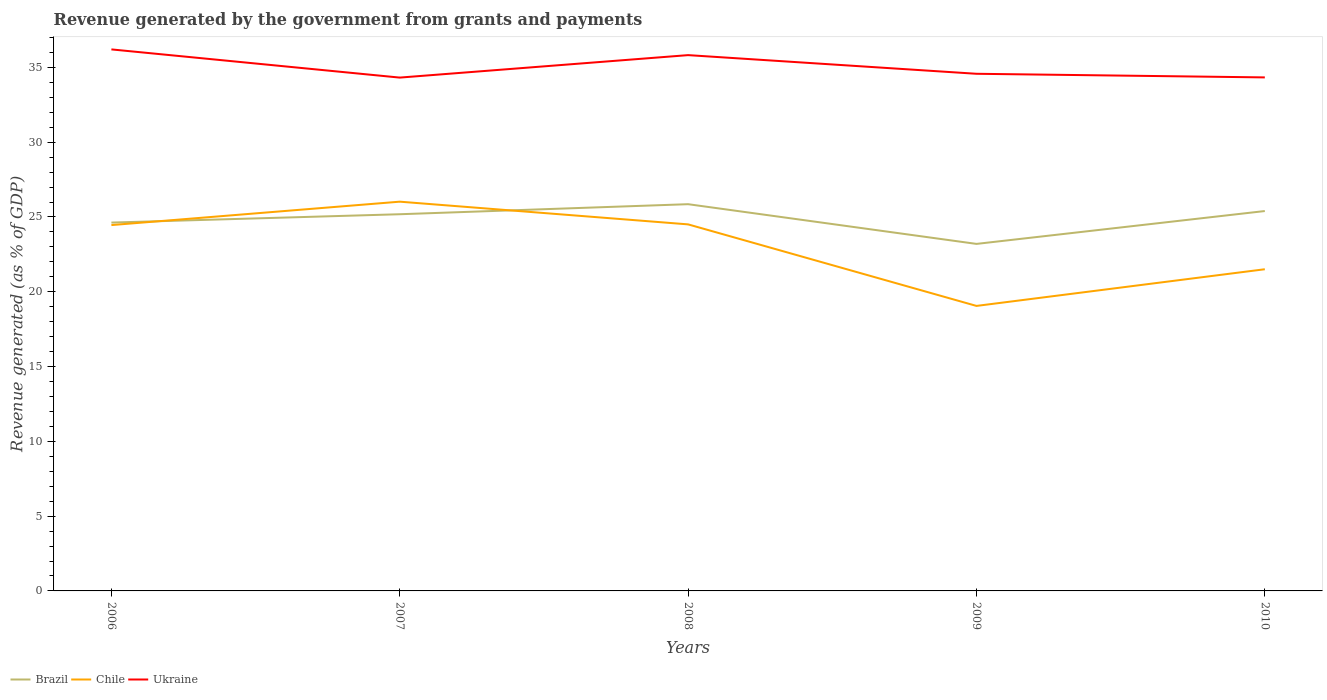How many different coloured lines are there?
Your answer should be very brief. 3. Is the number of lines equal to the number of legend labels?
Give a very brief answer. Yes. Across all years, what is the maximum revenue generated by the government in Chile?
Your answer should be compact. 19.05. In which year was the revenue generated by the government in Chile maximum?
Offer a very short reply. 2009. What is the total revenue generated by the government in Chile in the graph?
Your answer should be compact. 5.4. What is the difference between the highest and the second highest revenue generated by the government in Ukraine?
Provide a short and direct response. 1.88. How many lines are there?
Give a very brief answer. 3. What is the difference between two consecutive major ticks on the Y-axis?
Offer a terse response. 5. Does the graph contain any zero values?
Make the answer very short. No. Where does the legend appear in the graph?
Offer a terse response. Bottom left. What is the title of the graph?
Make the answer very short. Revenue generated by the government from grants and payments. What is the label or title of the Y-axis?
Your response must be concise. Revenue generated (as % of GDP). What is the Revenue generated (as % of GDP) in Brazil in 2006?
Make the answer very short. 24.63. What is the Revenue generated (as % of GDP) in Chile in 2006?
Your answer should be very brief. 24.46. What is the Revenue generated (as % of GDP) in Ukraine in 2006?
Make the answer very short. 36.2. What is the Revenue generated (as % of GDP) in Brazil in 2007?
Give a very brief answer. 25.18. What is the Revenue generated (as % of GDP) in Chile in 2007?
Your response must be concise. 26.02. What is the Revenue generated (as % of GDP) of Ukraine in 2007?
Your answer should be compact. 34.32. What is the Revenue generated (as % of GDP) in Brazil in 2008?
Provide a short and direct response. 25.86. What is the Revenue generated (as % of GDP) of Chile in 2008?
Ensure brevity in your answer.  24.51. What is the Revenue generated (as % of GDP) of Ukraine in 2008?
Keep it short and to the point. 35.82. What is the Revenue generated (as % of GDP) in Brazil in 2009?
Keep it short and to the point. 23.2. What is the Revenue generated (as % of GDP) in Chile in 2009?
Provide a succinct answer. 19.05. What is the Revenue generated (as % of GDP) in Ukraine in 2009?
Ensure brevity in your answer.  34.58. What is the Revenue generated (as % of GDP) in Brazil in 2010?
Provide a short and direct response. 25.4. What is the Revenue generated (as % of GDP) of Chile in 2010?
Make the answer very short. 21.51. What is the Revenue generated (as % of GDP) of Ukraine in 2010?
Your answer should be compact. 34.33. Across all years, what is the maximum Revenue generated (as % of GDP) of Brazil?
Provide a succinct answer. 25.86. Across all years, what is the maximum Revenue generated (as % of GDP) of Chile?
Provide a short and direct response. 26.02. Across all years, what is the maximum Revenue generated (as % of GDP) of Ukraine?
Provide a short and direct response. 36.2. Across all years, what is the minimum Revenue generated (as % of GDP) of Brazil?
Offer a terse response. 23.2. Across all years, what is the minimum Revenue generated (as % of GDP) in Chile?
Offer a terse response. 19.05. Across all years, what is the minimum Revenue generated (as % of GDP) in Ukraine?
Your answer should be compact. 34.32. What is the total Revenue generated (as % of GDP) in Brazil in the graph?
Your response must be concise. 124.27. What is the total Revenue generated (as % of GDP) of Chile in the graph?
Give a very brief answer. 115.55. What is the total Revenue generated (as % of GDP) of Ukraine in the graph?
Provide a succinct answer. 175.25. What is the difference between the Revenue generated (as % of GDP) of Brazil in 2006 and that in 2007?
Offer a terse response. -0.56. What is the difference between the Revenue generated (as % of GDP) in Chile in 2006 and that in 2007?
Make the answer very short. -1.57. What is the difference between the Revenue generated (as % of GDP) in Ukraine in 2006 and that in 2007?
Provide a succinct answer. 1.88. What is the difference between the Revenue generated (as % of GDP) in Brazil in 2006 and that in 2008?
Ensure brevity in your answer.  -1.23. What is the difference between the Revenue generated (as % of GDP) in Chile in 2006 and that in 2008?
Keep it short and to the point. -0.05. What is the difference between the Revenue generated (as % of GDP) of Ukraine in 2006 and that in 2008?
Offer a very short reply. 0.38. What is the difference between the Revenue generated (as % of GDP) in Brazil in 2006 and that in 2009?
Offer a very short reply. 1.43. What is the difference between the Revenue generated (as % of GDP) in Chile in 2006 and that in 2009?
Provide a succinct answer. 5.4. What is the difference between the Revenue generated (as % of GDP) of Ukraine in 2006 and that in 2009?
Your answer should be very brief. 1.63. What is the difference between the Revenue generated (as % of GDP) in Brazil in 2006 and that in 2010?
Give a very brief answer. -0.77. What is the difference between the Revenue generated (as % of GDP) in Chile in 2006 and that in 2010?
Provide a succinct answer. 2.95. What is the difference between the Revenue generated (as % of GDP) in Ukraine in 2006 and that in 2010?
Ensure brevity in your answer.  1.87. What is the difference between the Revenue generated (as % of GDP) of Brazil in 2007 and that in 2008?
Ensure brevity in your answer.  -0.67. What is the difference between the Revenue generated (as % of GDP) of Chile in 2007 and that in 2008?
Your answer should be very brief. 1.52. What is the difference between the Revenue generated (as % of GDP) in Ukraine in 2007 and that in 2008?
Ensure brevity in your answer.  -1.5. What is the difference between the Revenue generated (as % of GDP) in Brazil in 2007 and that in 2009?
Make the answer very short. 1.98. What is the difference between the Revenue generated (as % of GDP) of Chile in 2007 and that in 2009?
Your answer should be very brief. 6.97. What is the difference between the Revenue generated (as % of GDP) of Ukraine in 2007 and that in 2009?
Provide a succinct answer. -0.26. What is the difference between the Revenue generated (as % of GDP) in Brazil in 2007 and that in 2010?
Provide a succinct answer. -0.21. What is the difference between the Revenue generated (as % of GDP) of Chile in 2007 and that in 2010?
Your answer should be very brief. 4.52. What is the difference between the Revenue generated (as % of GDP) of Ukraine in 2007 and that in 2010?
Give a very brief answer. -0.01. What is the difference between the Revenue generated (as % of GDP) of Brazil in 2008 and that in 2009?
Your response must be concise. 2.65. What is the difference between the Revenue generated (as % of GDP) of Chile in 2008 and that in 2009?
Provide a succinct answer. 5.45. What is the difference between the Revenue generated (as % of GDP) of Ukraine in 2008 and that in 2009?
Make the answer very short. 1.25. What is the difference between the Revenue generated (as % of GDP) in Brazil in 2008 and that in 2010?
Keep it short and to the point. 0.46. What is the difference between the Revenue generated (as % of GDP) in Chile in 2008 and that in 2010?
Provide a short and direct response. 3. What is the difference between the Revenue generated (as % of GDP) of Ukraine in 2008 and that in 2010?
Provide a succinct answer. 1.49. What is the difference between the Revenue generated (as % of GDP) of Brazil in 2009 and that in 2010?
Make the answer very short. -2.2. What is the difference between the Revenue generated (as % of GDP) in Chile in 2009 and that in 2010?
Your response must be concise. -2.45. What is the difference between the Revenue generated (as % of GDP) of Ukraine in 2009 and that in 2010?
Your answer should be compact. 0.24. What is the difference between the Revenue generated (as % of GDP) in Brazil in 2006 and the Revenue generated (as % of GDP) in Chile in 2007?
Provide a short and direct response. -1.4. What is the difference between the Revenue generated (as % of GDP) of Brazil in 2006 and the Revenue generated (as % of GDP) of Ukraine in 2007?
Your answer should be very brief. -9.69. What is the difference between the Revenue generated (as % of GDP) of Chile in 2006 and the Revenue generated (as % of GDP) of Ukraine in 2007?
Offer a very short reply. -9.86. What is the difference between the Revenue generated (as % of GDP) in Brazil in 2006 and the Revenue generated (as % of GDP) in Chile in 2008?
Your response must be concise. 0.12. What is the difference between the Revenue generated (as % of GDP) of Brazil in 2006 and the Revenue generated (as % of GDP) of Ukraine in 2008?
Offer a terse response. -11.2. What is the difference between the Revenue generated (as % of GDP) in Chile in 2006 and the Revenue generated (as % of GDP) in Ukraine in 2008?
Give a very brief answer. -11.36. What is the difference between the Revenue generated (as % of GDP) of Brazil in 2006 and the Revenue generated (as % of GDP) of Chile in 2009?
Your answer should be very brief. 5.57. What is the difference between the Revenue generated (as % of GDP) of Brazil in 2006 and the Revenue generated (as % of GDP) of Ukraine in 2009?
Keep it short and to the point. -9.95. What is the difference between the Revenue generated (as % of GDP) in Chile in 2006 and the Revenue generated (as % of GDP) in Ukraine in 2009?
Provide a succinct answer. -10.12. What is the difference between the Revenue generated (as % of GDP) of Brazil in 2006 and the Revenue generated (as % of GDP) of Chile in 2010?
Your answer should be compact. 3.12. What is the difference between the Revenue generated (as % of GDP) in Brazil in 2006 and the Revenue generated (as % of GDP) in Ukraine in 2010?
Offer a terse response. -9.71. What is the difference between the Revenue generated (as % of GDP) in Chile in 2006 and the Revenue generated (as % of GDP) in Ukraine in 2010?
Ensure brevity in your answer.  -9.87. What is the difference between the Revenue generated (as % of GDP) of Brazil in 2007 and the Revenue generated (as % of GDP) of Chile in 2008?
Your answer should be compact. 0.68. What is the difference between the Revenue generated (as % of GDP) in Brazil in 2007 and the Revenue generated (as % of GDP) in Ukraine in 2008?
Your response must be concise. -10.64. What is the difference between the Revenue generated (as % of GDP) in Chile in 2007 and the Revenue generated (as % of GDP) in Ukraine in 2008?
Your answer should be very brief. -9.8. What is the difference between the Revenue generated (as % of GDP) in Brazil in 2007 and the Revenue generated (as % of GDP) in Chile in 2009?
Give a very brief answer. 6.13. What is the difference between the Revenue generated (as % of GDP) of Brazil in 2007 and the Revenue generated (as % of GDP) of Ukraine in 2009?
Provide a short and direct response. -9.39. What is the difference between the Revenue generated (as % of GDP) of Chile in 2007 and the Revenue generated (as % of GDP) of Ukraine in 2009?
Your answer should be very brief. -8.55. What is the difference between the Revenue generated (as % of GDP) in Brazil in 2007 and the Revenue generated (as % of GDP) in Chile in 2010?
Offer a very short reply. 3.68. What is the difference between the Revenue generated (as % of GDP) in Brazil in 2007 and the Revenue generated (as % of GDP) in Ukraine in 2010?
Give a very brief answer. -9.15. What is the difference between the Revenue generated (as % of GDP) in Chile in 2007 and the Revenue generated (as % of GDP) in Ukraine in 2010?
Keep it short and to the point. -8.31. What is the difference between the Revenue generated (as % of GDP) of Brazil in 2008 and the Revenue generated (as % of GDP) of Chile in 2009?
Your response must be concise. 6.8. What is the difference between the Revenue generated (as % of GDP) of Brazil in 2008 and the Revenue generated (as % of GDP) of Ukraine in 2009?
Your answer should be compact. -8.72. What is the difference between the Revenue generated (as % of GDP) of Chile in 2008 and the Revenue generated (as % of GDP) of Ukraine in 2009?
Your answer should be compact. -10.07. What is the difference between the Revenue generated (as % of GDP) in Brazil in 2008 and the Revenue generated (as % of GDP) in Chile in 2010?
Provide a succinct answer. 4.35. What is the difference between the Revenue generated (as % of GDP) in Brazil in 2008 and the Revenue generated (as % of GDP) in Ukraine in 2010?
Offer a very short reply. -8.48. What is the difference between the Revenue generated (as % of GDP) of Chile in 2008 and the Revenue generated (as % of GDP) of Ukraine in 2010?
Keep it short and to the point. -9.83. What is the difference between the Revenue generated (as % of GDP) of Brazil in 2009 and the Revenue generated (as % of GDP) of Chile in 2010?
Your response must be concise. 1.69. What is the difference between the Revenue generated (as % of GDP) in Brazil in 2009 and the Revenue generated (as % of GDP) in Ukraine in 2010?
Offer a terse response. -11.13. What is the difference between the Revenue generated (as % of GDP) of Chile in 2009 and the Revenue generated (as % of GDP) of Ukraine in 2010?
Your answer should be compact. -15.28. What is the average Revenue generated (as % of GDP) in Brazil per year?
Offer a very short reply. 24.85. What is the average Revenue generated (as % of GDP) in Chile per year?
Provide a succinct answer. 23.11. What is the average Revenue generated (as % of GDP) of Ukraine per year?
Your response must be concise. 35.05. In the year 2006, what is the difference between the Revenue generated (as % of GDP) of Brazil and Revenue generated (as % of GDP) of Chile?
Keep it short and to the point. 0.17. In the year 2006, what is the difference between the Revenue generated (as % of GDP) of Brazil and Revenue generated (as % of GDP) of Ukraine?
Give a very brief answer. -11.58. In the year 2006, what is the difference between the Revenue generated (as % of GDP) in Chile and Revenue generated (as % of GDP) in Ukraine?
Offer a terse response. -11.75. In the year 2007, what is the difference between the Revenue generated (as % of GDP) in Brazil and Revenue generated (as % of GDP) in Chile?
Ensure brevity in your answer.  -0.84. In the year 2007, what is the difference between the Revenue generated (as % of GDP) of Brazil and Revenue generated (as % of GDP) of Ukraine?
Offer a very short reply. -9.14. In the year 2007, what is the difference between the Revenue generated (as % of GDP) of Chile and Revenue generated (as % of GDP) of Ukraine?
Your response must be concise. -8.3. In the year 2008, what is the difference between the Revenue generated (as % of GDP) of Brazil and Revenue generated (as % of GDP) of Chile?
Offer a very short reply. 1.35. In the year 2008, what is the difference between the Revenue generated (as % of GDP) in Brazil and Revenue generated (as % of GDP) in Ukraine?
Provide a succinct answer. -9.97. In the year 2008, what is the difference between the Revenue generated (as % of GDP) in Chile and Revenue generated (as % of GDP) in Ukraine?
Your response must be concise. -11.32. In the year 2009, what is the difference between the Revenue generated (as % of GDP) in Brazil and Revenue generated (as % of GDP) in Chile?
Your answer should be very brief. 4.15. In the year 2009, what is the difference between the Revenue generated (as % of GDP) in Brazil and Revenue generated (as % of GDP) in Ukraine?
Provide a short and direct response. -11.37. In the year 2009, what is the difference between the Revenue generated (as % of GDP) of Chile and Revenue generated (as % of GDP) of Ukraine?
Make the answer very short. -15.52. In the year 2010, what is the difference between the Revenue generated (as % of GDP) of Brazil and Revenue generated (as % of GDP) of Chile?
Keep it short and to the point. 3.89. In the year 2010, what is the difference between the Revenue generated (as % of GDP) in Brazil and Revenue generated (as % of GDP) in Ukraine?
Your answer should be compact. -8.93. In the year 2010, what is the difference between the Revenue generated (as % of GDP) of Chile and Revenue generated (as % of GDP) of Ukraine?
Make the answer very short. -12.83. What is the ratio of the Revenue generated (as % of GDP) in Brazil in 2006 to that in 2007?
Offer a terse response. 0.98. What is the ratio of the Revenue generated (as % of GDP) in Chile in 2006 to that in 2007?
Your answer should be compact. 0.94. What is the ratio of the Revenue generated (as % of GDP) of Ukraine in 2006 to that in 2007?
Provide a short and direct response. 1.05. What is the ratio of the Revenue generated (as % of GDP) in Brazil in 2006 to that in 2008?
Provide a succinct answer. 0.95. What is the ratio of the Revenue generated (as % of GDP) in Ukraine in 2006 to that in 2008?
Provide a succinct answer. 1.01. What is the ratio of the Revenue generated (as % of GDP) of Brazil in 2006 to that in 2009?
Your response must be concise. 1.06. What is the ratio of the Revenue generated (as % of GDP) in Chile in 2006 to that in 2009?
Give a very brief answer. 1.28. What is the ratio of the Revenue generated (as % of GDP) of Ukraine in 2006 to that in 2009?
Make the answer very short. 1.05. What is the ratio of the Revenue generated (as % of GDP) of Brazil in 2006 to that in 2010?
Offer a terse response. 0.97. What is the ratio of the Revenue generated (as % of GDP) in Chile in 2006 to that in 2010?
Keep it short and to the point. 1.14. What is the ratio of the Revenue generated (as % of GDP) in Ukraine in 2006 to that in 2010?
Your answer should be very brief. 1.05. What is the ratio of the Revenue generated (as % of GDP) of Brazil in 2007 to that in 2008?
Offer a very short reply. 0.97. What is the ratio of the Revenue generated (as % of GDP) in Chile in 2007 to that in 2008?
Your answer should be very brief. 1.06. What is the ratio of the Revenue generated (as % of GDP) in Ukraine in 2007 to that in 2008?
Keep it short and to the point. 0.96. What is the ratio of the Revenue generated (as % of GDP) in Brazil in 2007 to that in 2009?
Make the answer very short. 1.09. What is the ratio of the Revenue generated (as % of GDP) in Chile in 2007 to that in 2009?
Offer a very short reply. 1.37. What is the ratio of the Revenue generated (as % of GDP) in Brazil in 2007 to that in 2010?
Provide a short and direct response. 0.99. What is the ratio of the Revenue generated (as % of GDP) in Chile in 2007 to that in 2010?
Your response must be concise. 1.21. What is the ratio of the Revenue generated (as % of GDP) in Brazil in 2008 to that in 2009?
Provide a succinct answer. 1.11. What is the ratio of the Revenue generated (as % of GDP) of Chile in 2008 to that in 2009?
Provide a short and direct response. 1.29. What is the ratio of the Revenue generated (as % of GDP) of Ukraine in 2008 to that in 2009?
Provide a short and direct response. 1.04. What is the ratio of the Revenue generated (as % of GDP) in Brazil in 2008 to that in 2010?
Ensure brevity in your answer.  1.02. What is the ratio of the Revenue generated (as % of GDP) in Chile in 2008 to that in 2010?
Give a very brief answer. 1.14. What is the ratio of the Revenue generated (as % of GDP) of Ukraine in 2008 to that in 2010?
Give a very brief answer. 1.04. What is the ratio of the Revenue generated (as % of GDP) in Brazil in 2009 to that in 2010?
Your response must be concise. 0.91. What is the ratio of the Revenue generated (as % of GDP) of Chile in 2009 to that in 2010?
Ensure brevity in your answer.  0.89. What is the ratio of the Revenue generated (as % of GDP) in Ukraine in 2009 to that in 2010?
Your response must be concise. 1.01. What is the difference between the highest and the second highest Revenue generated (as % of GDP) in Brazil?
Ensure brevity in your answer.  0.46. What is the difference between the highest and the second highest Revenue generated (as % of GDP) of Chile?
Your answer should be compact. 1.52. What is the difference between the highest and the second highest Revenue generated (as % of GDP) in Ukraine?
Give a very brief answer. 0.38. What is the difference between the highest and the lowest Revenue generated (as % of GDP) in Brazil?
Make the answer very short. 2.65. What is the difference between the highest and the lowest Revenue generated (as % of GDP) of Chile?
Keep it short and to the point. 6.97. What is the difference between the highest and the lowest Revenue generated (as % of GDP) in Ukraine?
Your answer should be very brief. 1.88. 